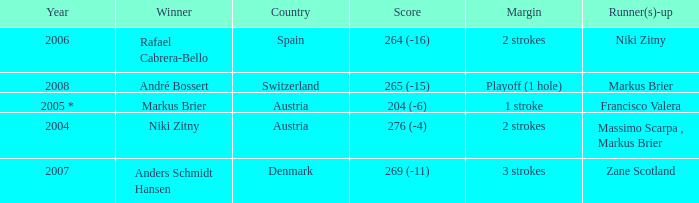What was the country when the margin was 2 strokes, and when the score was 276 (-4)? Austria. 